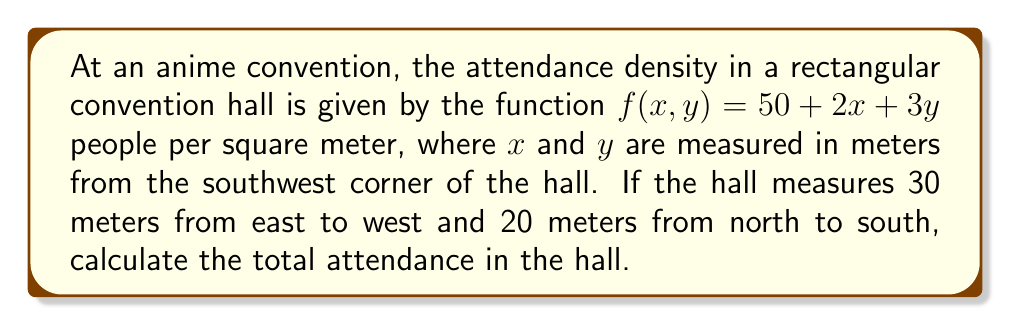Can you answer this question? To solve this problem, we need to evaluate a double integral over the given rectangular region. The steps are as follows:

1) The function $f(x,y) = 50 + 2x + 3y$ represents the attendance density at any point $(x,y)$ in the hall.

2) The hall's dimensions are 30 meters (east-west) by 20 meters (north-south). This gives us our limits of integration:
   $0 \leq x \leq 30$ and $0 \leq y \leq 20$

3) The total attendance is found by integrating the density function over the entire area:

   $$\iint_R f(x,y) \, dA = \int_0^{20} \int_0^{30} (50 + 2x + 3y) \, dx \, dy$$

4) Let's evaluate the inner integral first (with respect to x):

   $$\int_0^{20} \left[ \int_0^{30} (50 + 2x + 3y) \, dx \right] \, dy$$
   $$= \int_0^{20} \left[ 50x + x^2 + 3xy \right]_0^{30} \, dy$$
   $$= \int_0^{20} (1500 + 900 + 90y) \, dy$$

5) Now we can evaluate the outer integral:

   $$\int_0^{20} (2400 + 90y) \, dy$$
   $$= \left[ 2400y + 45y^2 \right]_0^{20}$$
   $$= (48000 + 18000) - (0 + 0)$$
   $$= 66000$$

Therefore, the total attendance in the convention hall is 66,000 people.
Answer: 66,000 people 